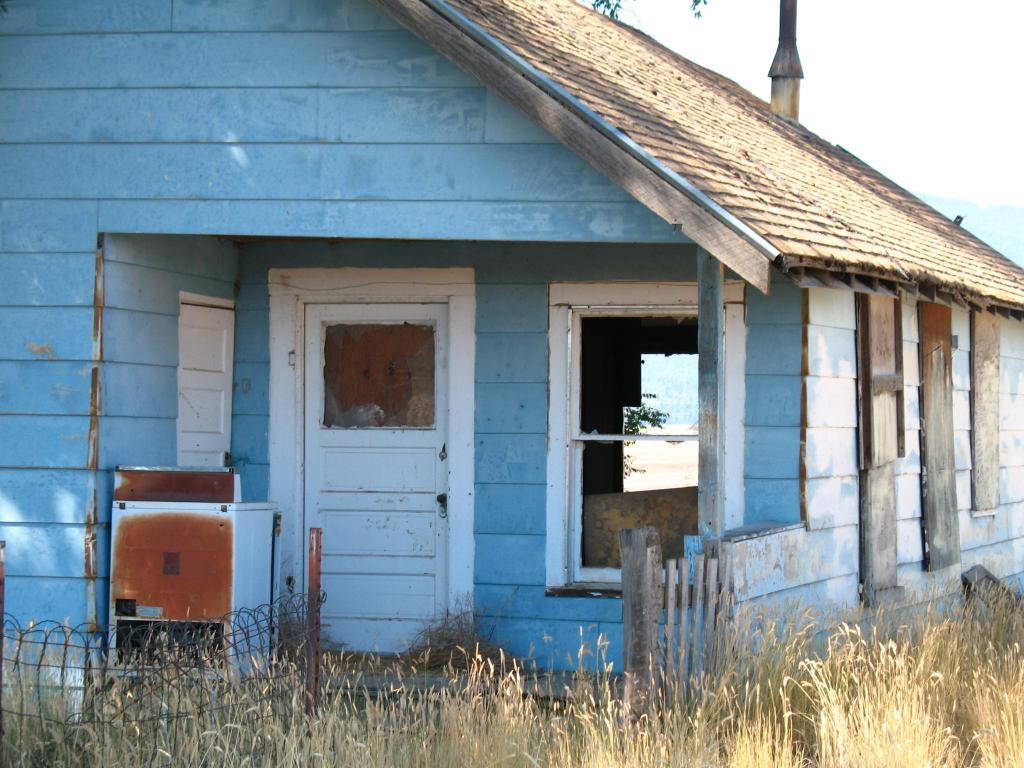What type of structure is in the picture? There is a house in the picture. What features can be seen on the house? The house has a roof top, a door, a window, and a railing. Are there any objects in the picture besides the house? Yes, there are objects in the picture. What can be seen at the bottom portion of the picture? Plants are visible at the bottom portion of the picture. Can you tell me how many potatoes are on the roof of the house in the image? There are no potatoes visible on the roof of the house in the image. What color is the robin sitting on the railing of the house in the image? There is no robin present on the railing of the house in the image. 